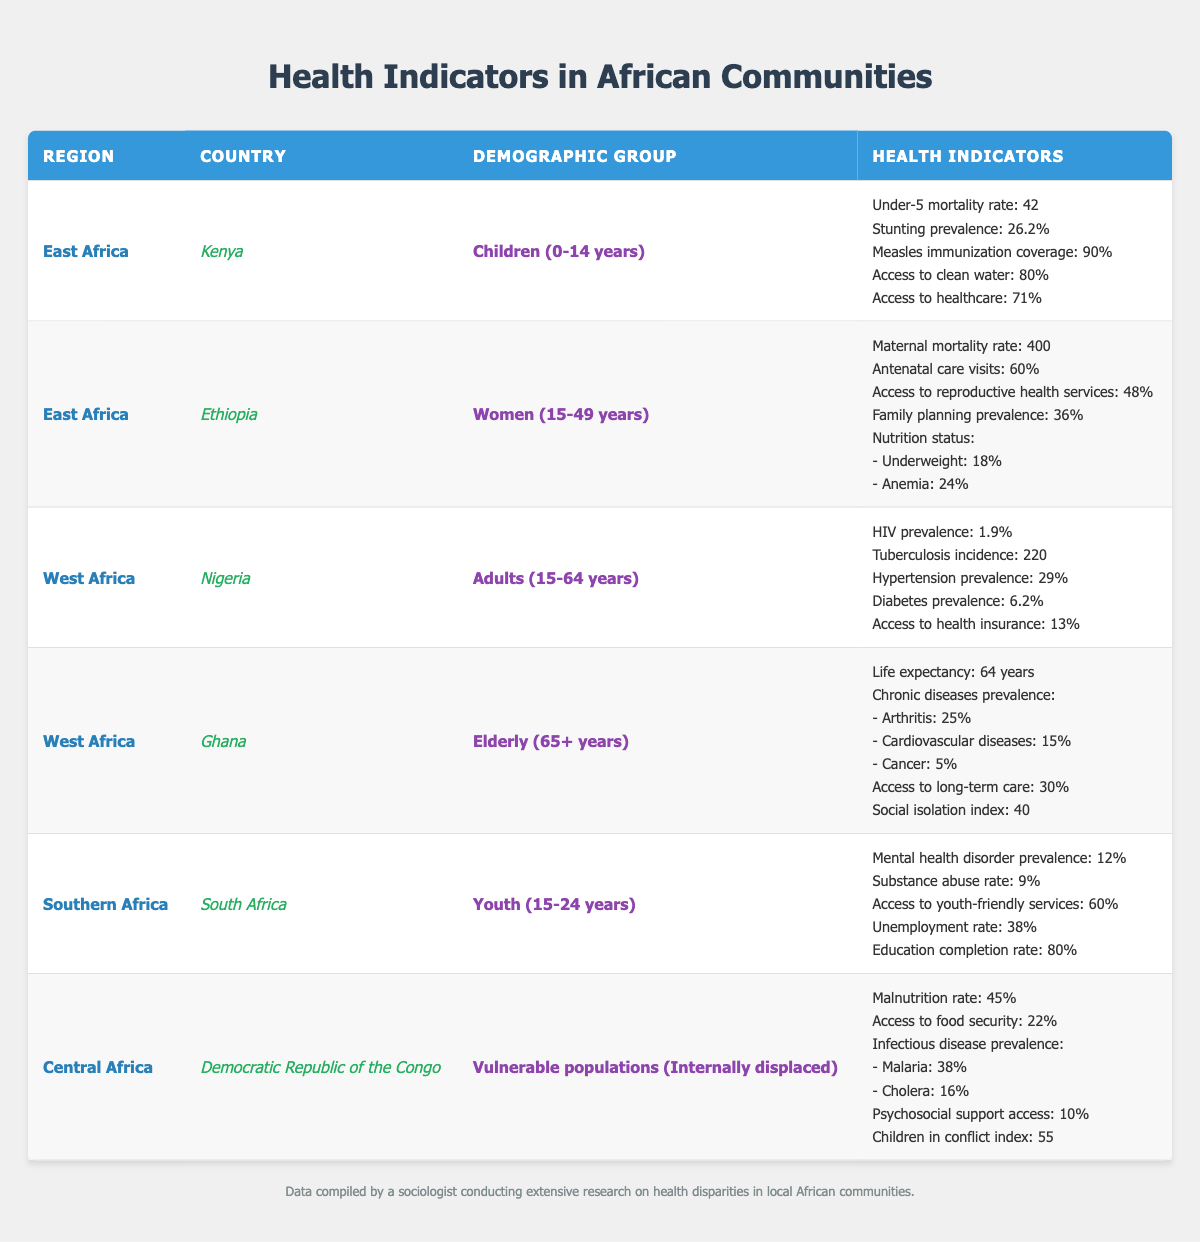What is the under-5 mortality rate in Kenya? The table indicates that the under-5 mortality rate for children in Kenya is presented, which is specified right after the demographic group. It shows the value as 42.
Answer: 42 What percentage of children in Kenya have access to clean water? Referring to the data for Kenya, the table shows that access to clean water for children is 80%.
Answer: 80% Which country has the highest maternal mortality rate? Among the listed countries, Ethiopia has a maternal mortality rate of 400, which is the highest compared to other entries in the table.
Answer: Ethiopia What is the life expectancy for the elderly in Ghana? The table provides the life expectancy for the elderly (65+ years) in Ghana, and it is stated to be 64 years.
Answer: 64 years Is the HIV prevalence among adults in Nigeria higher than 2%? The table shows that the HIV prevalence among adults in Nigeria is 1.9%, which is not higher than 2%.
Answer: No What is the average access to healthcare for children in Kenya and women in Ethiopia? Access to healthcare for children in Kenya is 71%, and for women in Ethiopia, it is not mentioned explicitly. However, assuming no value, we would only consider the known data, which is 71%. As there is no healthcare access data for Ethiopia provided in the table, the average cannot be calculated as one half of the sum is missing.
Answer: Cannot determine What is the proportion of stunting prevalence among children in East Africa compared to malnutrition rate among internally displaced populations in Central Africa? For children in East Africa (Kenya), the stunting prevalence is 26.2%. For the internally displaced populations in Central Africa (DR Congo), the malnutrition rate is 45%. Comparing these two values yields a difference of 45% - 26.2% = 18.8%. The stunting prevalence is lower than the malnutrition rate.
Answer: 26.2% is lower How does the education completion rate among youth in South Africa relate to access to youth-friendly services in the same country? In South Africa, the education completion rate for youth (15-24 years) is 80%, while access to youth-friendly services is reported at 60%. 80% indicates a higher completion rate in education compared to the 60% access to youth-friendly services. Therefore, education completion is more prevalent than access to such services.
Answer: Higher What regions are represented in the data? From the table, the regions identified are East Africa, West Africa, Southern Africa, and Central Africa.
Answer: Four regions Combine the hypertension prevalence and diabetes prevalence for adults in Nigeria. The table shows the hypertension prevalence as 29% and the diabetes prevalence as 6.2% for adults in Nigeria. Therefore, to combine these values, we sum them: 29% + 6.2% = 35.2%.
Answer: 35.2% What percentage of women in Ethiopia have access to reproductive health services? Looking at the data for women aged 15-49 years in Ethiopia, the table states that access to reproductive health services is 48%.
Answer: 48% 